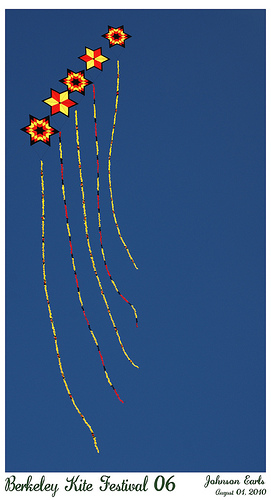<image>
Can you confirm if the kite is under the air? No. The kite is not positioned under the air. The vertical relationship between these objects is different. 